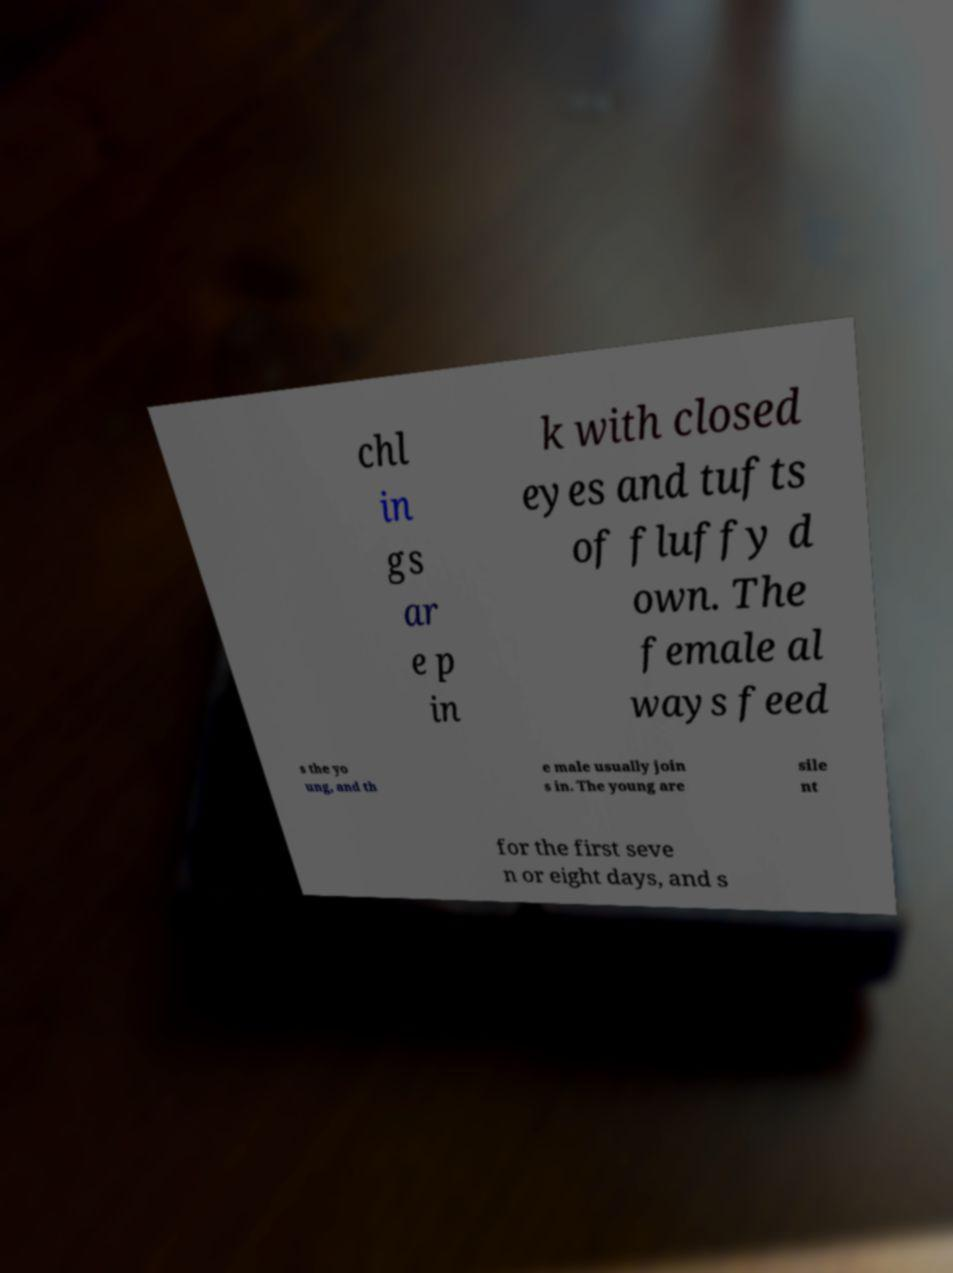Can you read and provide the text displayed in the image?This photo seems to have some interesting text. Can you extract and type it out for me? chl in gs ar e p in k with closed eyes and tufts of fluffy d own. The female al ways feed s the yo ung, and th e male usually join s in. The young are sile nt for the first seve n or eight days, and s 